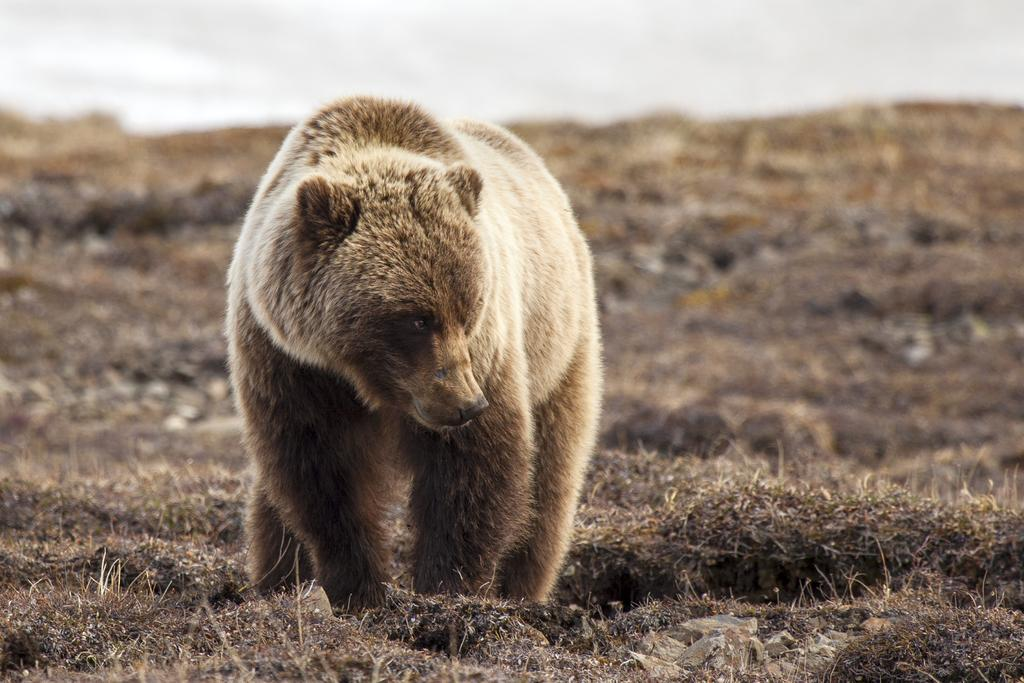What animal is present in the image? There is a bear in the image. What is the bear doing in the image? The bear is standing on the ground. What type of exchange is taking place between the bear and the cows in the image? There are no cows present in the image, and therefore no exchange can be observed. 